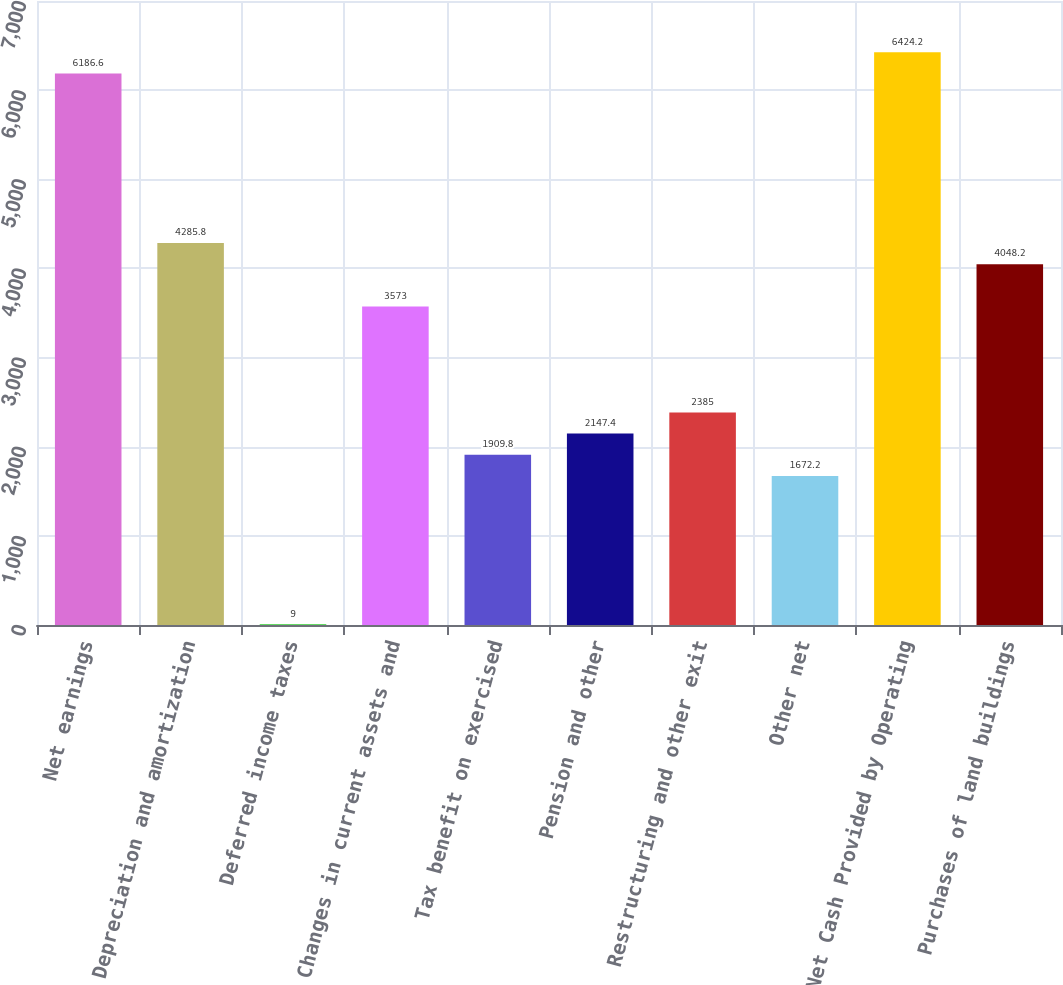Convert chart. <chart><loc_0><loc_0><loc_500><loc_500><bar_chart><fcel>Net earnings<fcel>Depreciation and amortization<fcel>Deferred income taxes<fcel>Changes in current assets and<fcel>Tax benefit on exercised<fcel>Pension and other<fcel>Restructuring and other exit<fcel>Other net<fcel>Net Cash Provided by Operating<fcel>Purchases of land buildings<nl><fcel>6186.6<fcel>4285.8<fcel>9<fcel>3573<fcel>1909.8<fcel>2147.4<fcel>2385<fcel>1672.2<fcel>6424.2<fcel>4048.2<nl></chart> 